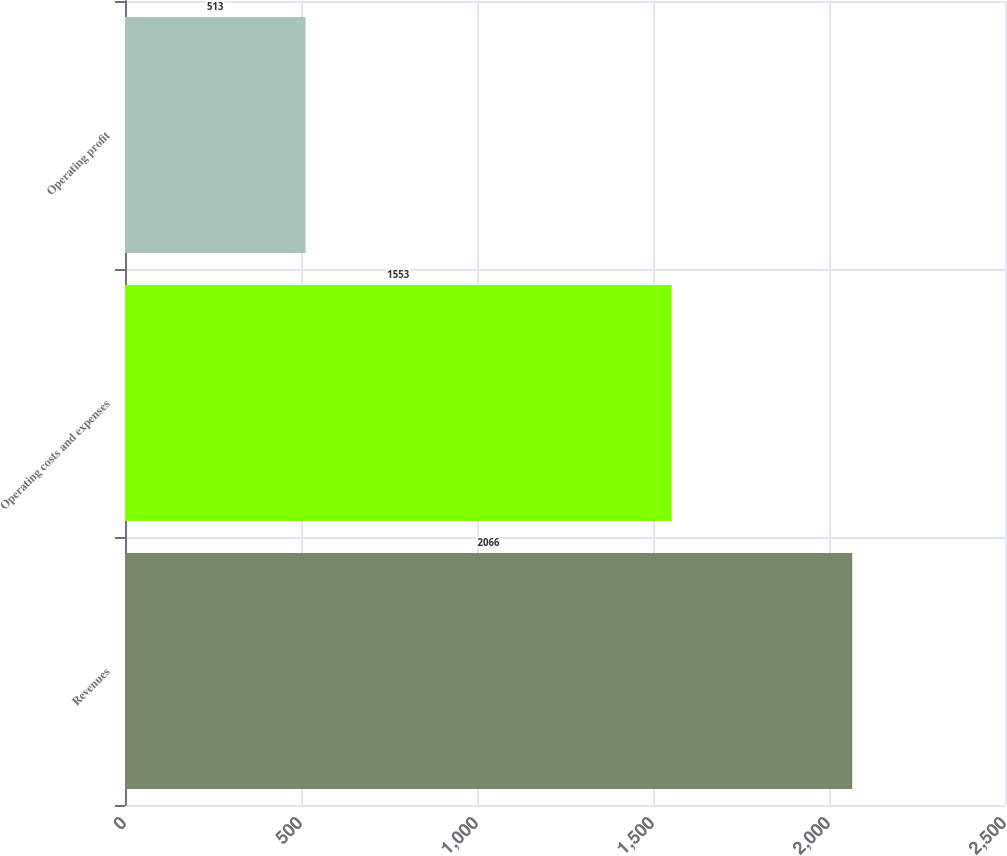Convert chart. <chart><loc_0><loc_0><loc_500><loc_500><bar_chart><fcel>Revenues<fcel>Operating costs and expenses<fcel>Operating profit<nl><fcel>2066<fcel>1553<fcel>513<nl></chart> 